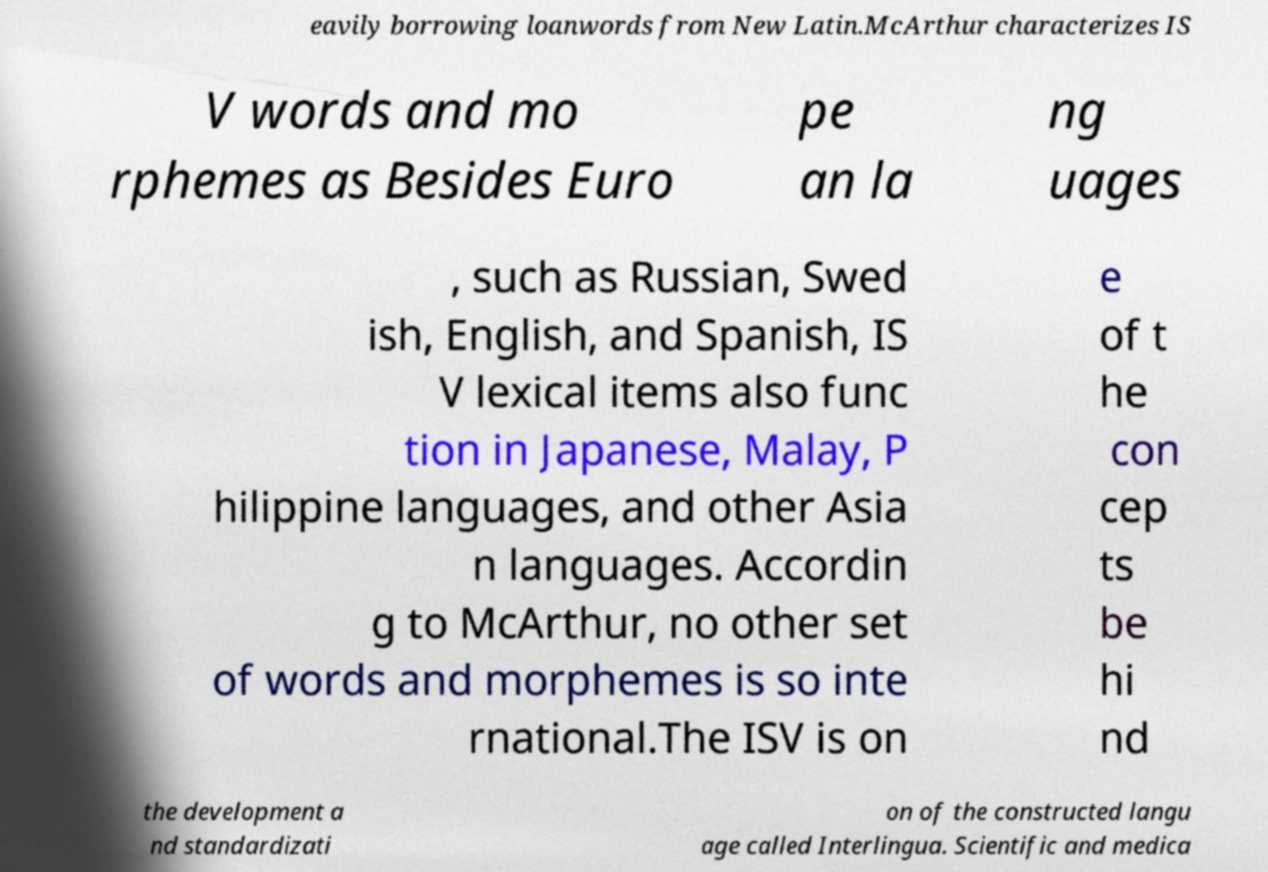What messages or text are displayed in this image? I need them in a readable, typed format. eavily borrowing loanwords from New Latin.McArthur characterizes IS V words and mo rphemes as Besides Euro pe an la ng uages , such as Russian, Swed ish, English, and Spanish, IS V lexical items also func tion in Japanese, Malay, P hilippine languages, and other Asia n languages. Accordin g to McArthur, no other set of words and morphemes is so inte rnational.The ISV is on e of t he con cep ts be hi nd the development a nd standardizati on of the constructed langu age called Interlingua. Scientific and medica 